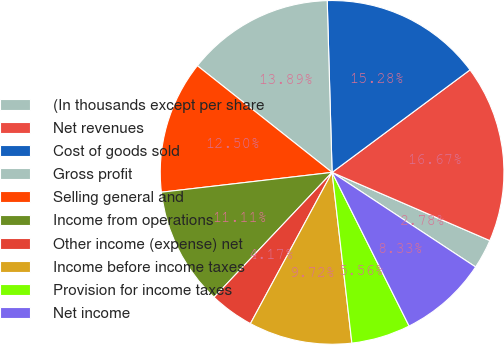<chart> <loc_0><loc_0><loc_500><loc_500><pie_chart><fcel>(In thousands except per share<fcel>Net revenues<fcel>Cost of goods sold<fcel>Gross profit<fcel>Selling general and<fcel>Income from operations<fcel>Other income (expense) net<fcel>Income before income taxes<fcel>Provision for income taxes<fcel>Net income<nl><fcel>2.78%<fcel>16.67%<fcel>15.28%<fcel>13.89%<fcel>12.5%<fcel>11.11%<fcel>4.17%<fcel>9.72%<fcel>5.56%<fcel>8.33%<nl></chart> 